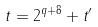Convert formula to latex. <formula><loc_0><loc_0><loc_500><loc_500>t = 2 ^ { q + 8 } + t ^ { \prime }</formula> 